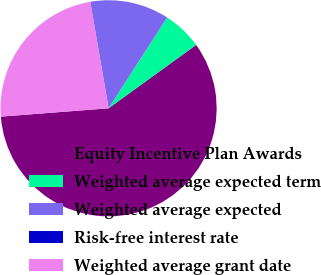Convert chart. <chart><loc_0><loc_0><loc_500><loc_500><pie_chart><fcel>Equity Incentive Plan Awards<fcel>Weighted average expected term<fcel>Weighted average expected<fcel>Risk-free interest rate<fcel>Weighted average grant date<nl><fcel>58.74%<fcel>5.91%<fcel>11.78%<fcel>0.04%<fcel>23.52%<nl></chart> 